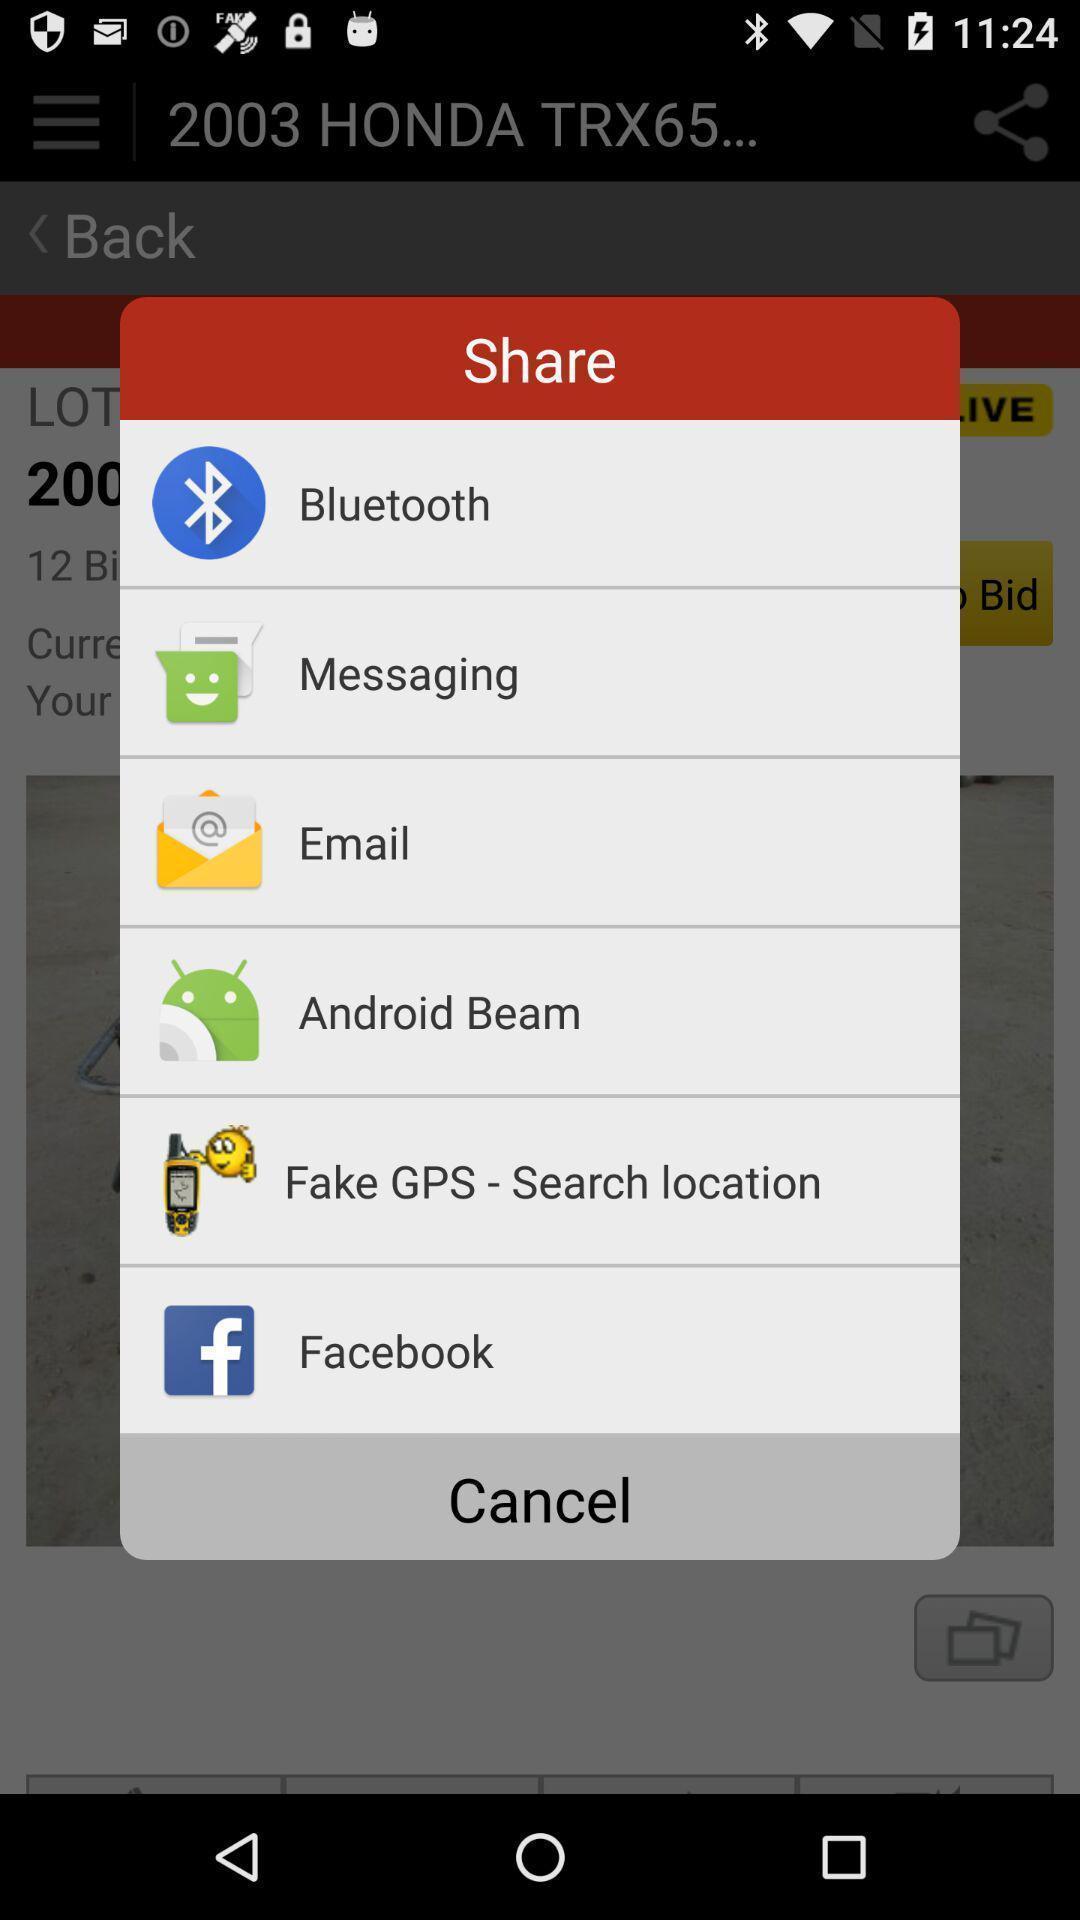Explain the elements present in this screenshot. Pop-up to share using different apps. 